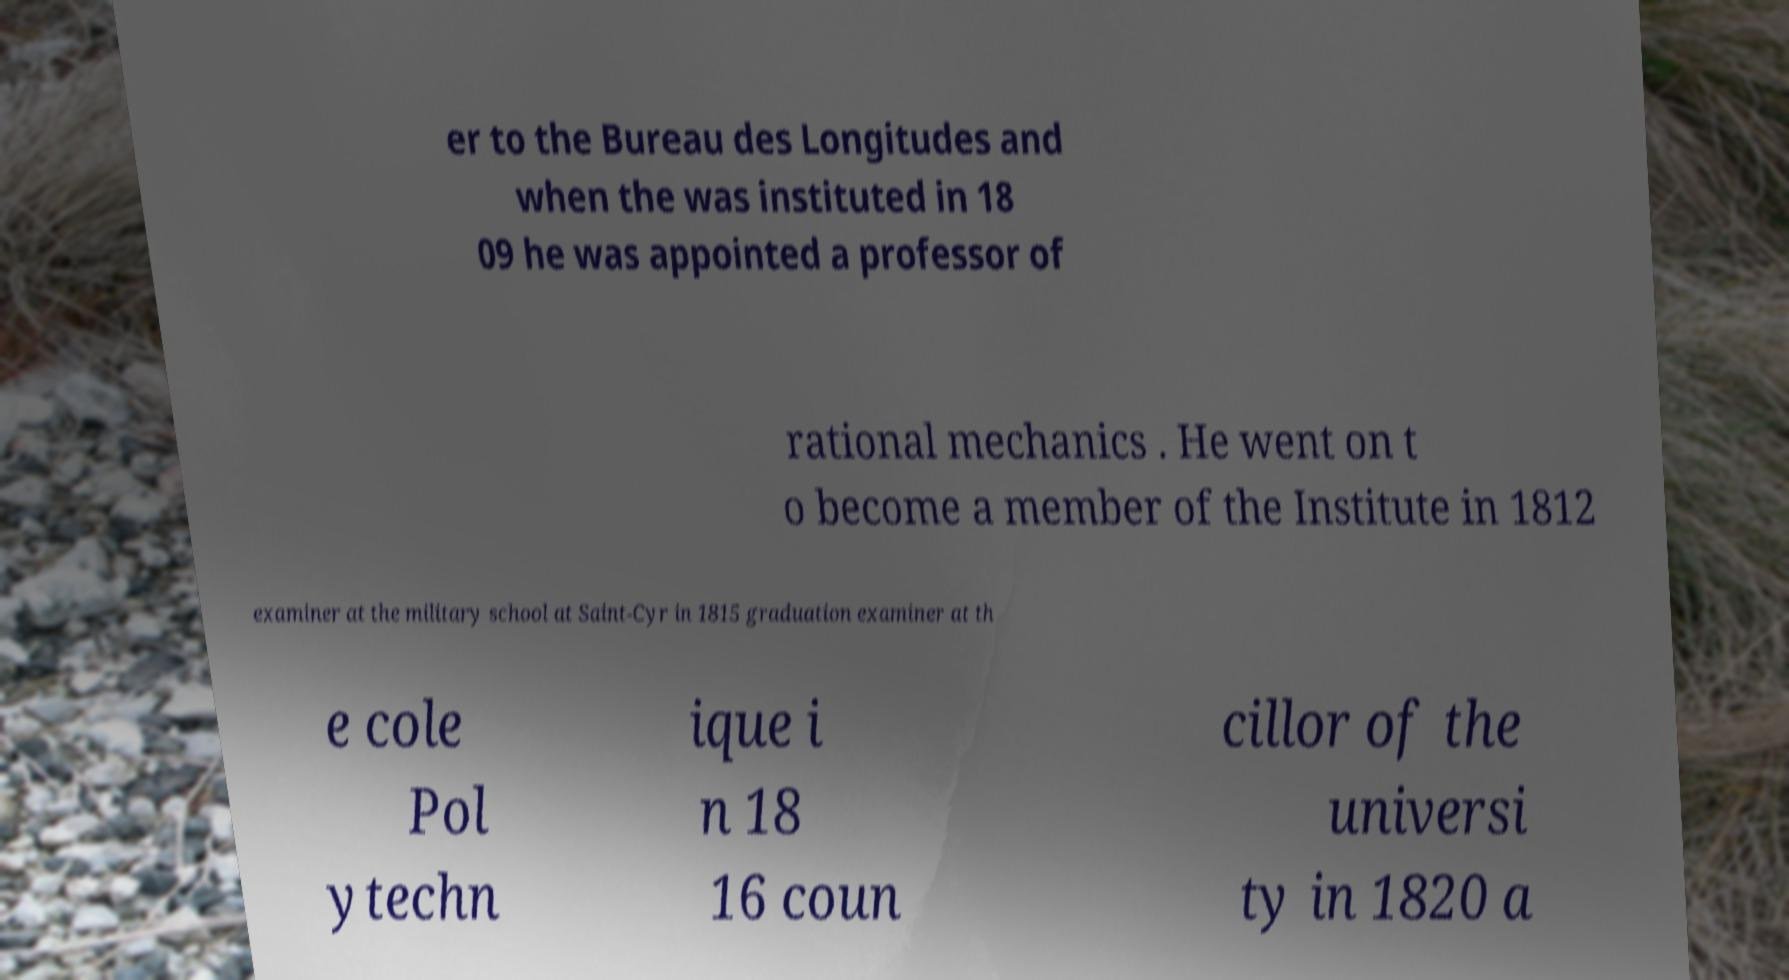What messages or text are displayed in this image? I need them in a readable, typed format. er to the Bureau des Longitudes and when the was instituted in 18 09 he was appointed a professor of rational mechanics . He went on t o become a member of the Institute in 1812 examiner at the military school at Saint-Cyr in 1815 graduation examiner at th e cole Pol ytechn ique i n 18 16 coun cillor of the universi ty in 1820 a 